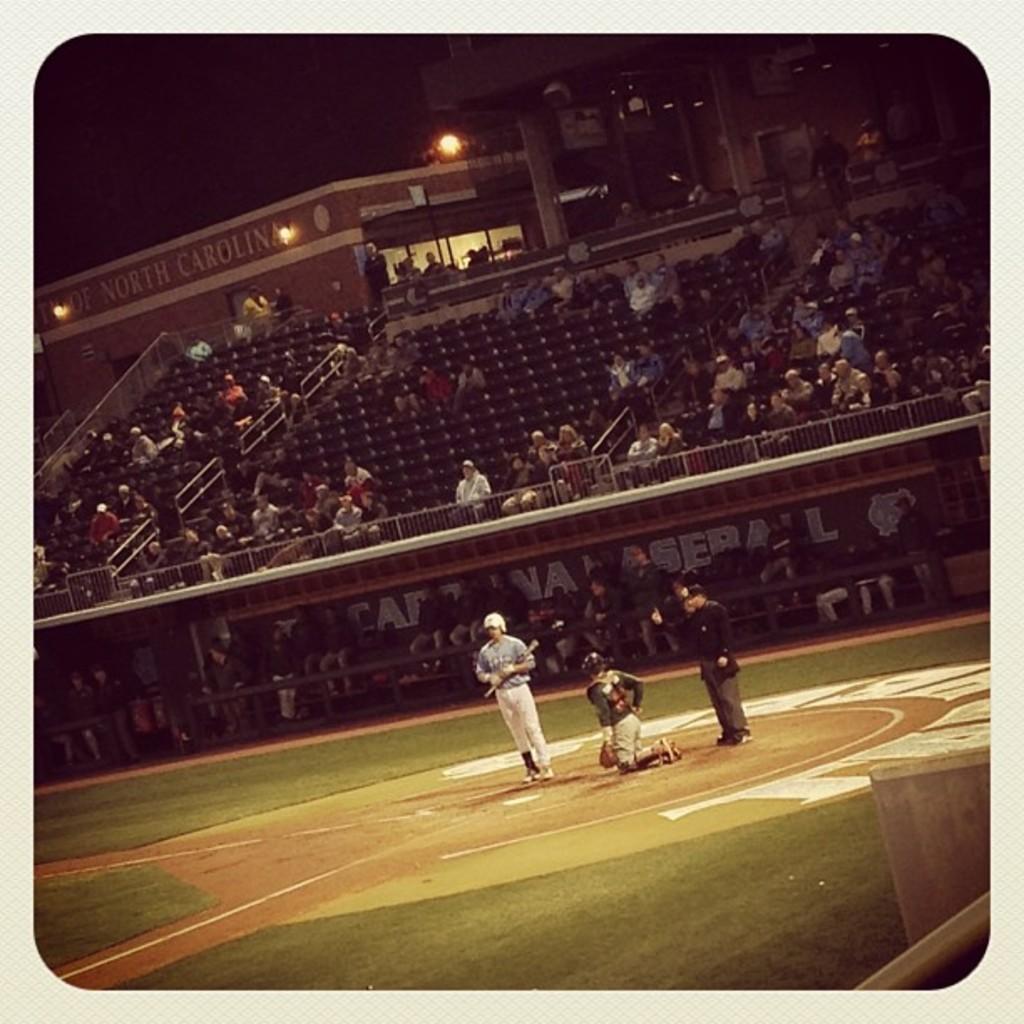What stadium is this?
Keep it short and to the point. North carolina. 